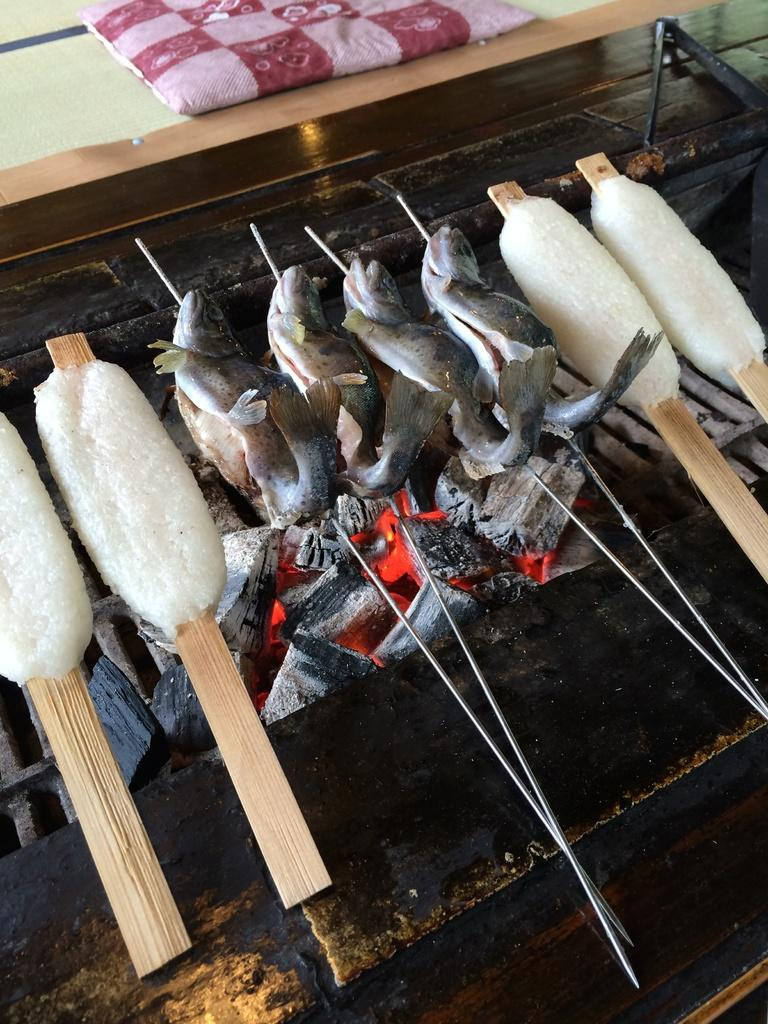What type of animals can be seen in the image? There are fish in the image. What is present alongside the fish in the image? There is ice in the image. Where are the fish and ice located in the image? The fish and ice are placed on a grill and are in the center of the image. What type of furniture is depicted in the image? There is no furniture present in the image; it features fish and ice on a grill. How does the image reflect the development of a particular region? The image does not depict any development or regional context; it focuses on fish and ice on a grill. 